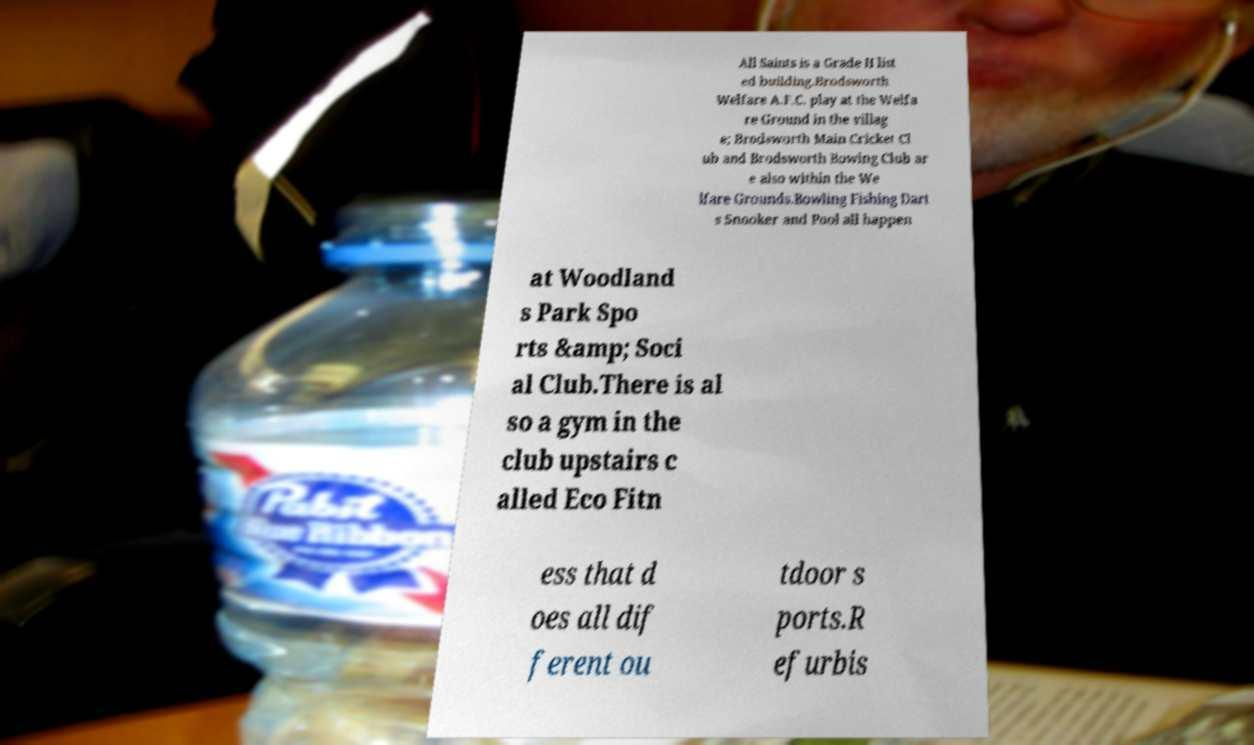There's text embedded in this image that I need extracted. Can you transcribe it verbatim? All Saints is a Grade II list ed building.Brodsworth Welfare A.F.C. play at the Welfa re Ground in the villag e; Brodsworth Main Cricket Cl ub and Brodsworth Bowing Club ar e also within the We lfare Grounds.Bowling Fishing Dart s Snooker and Pool all happen at Woodland s Park Spo rts &amp; Soci al Club.There is al so a gym in the club upstairs c alled Eco Fitn ess that d oes all dif ferent ou tdoor s ports.R efurbis 